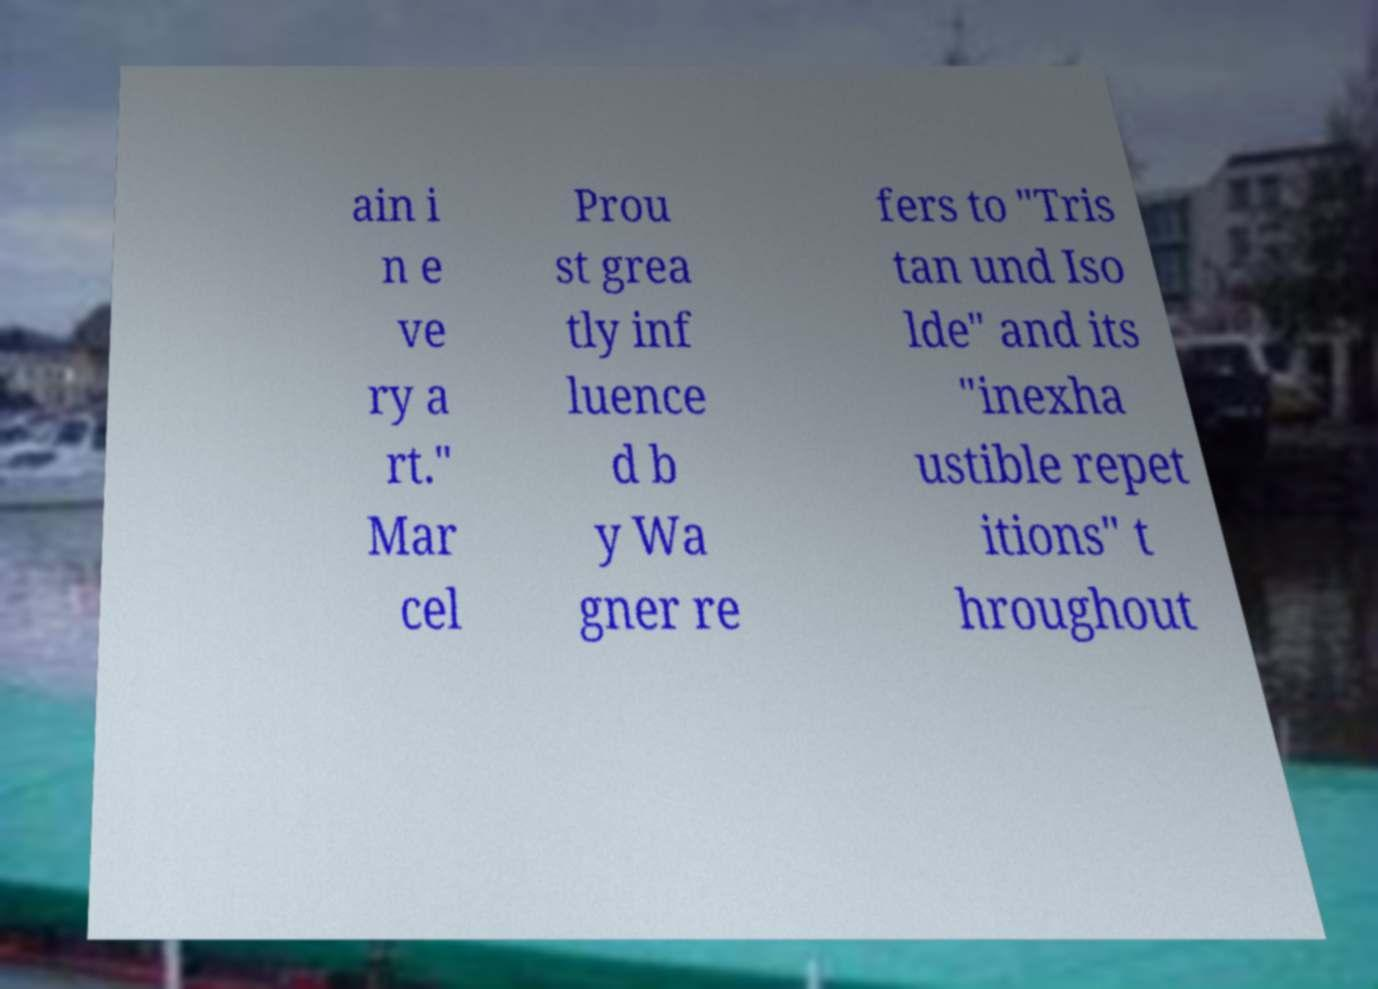There's text embedded in this image that I need extracted. Can you transcribe it verbatim? ain i n e ve ry a rt." Mar cel Prou st grea tly inf luence d b y Wa gner re fers to "Tris tan und Iso lde" and its "inexha ustible repet itions" t hroughout 